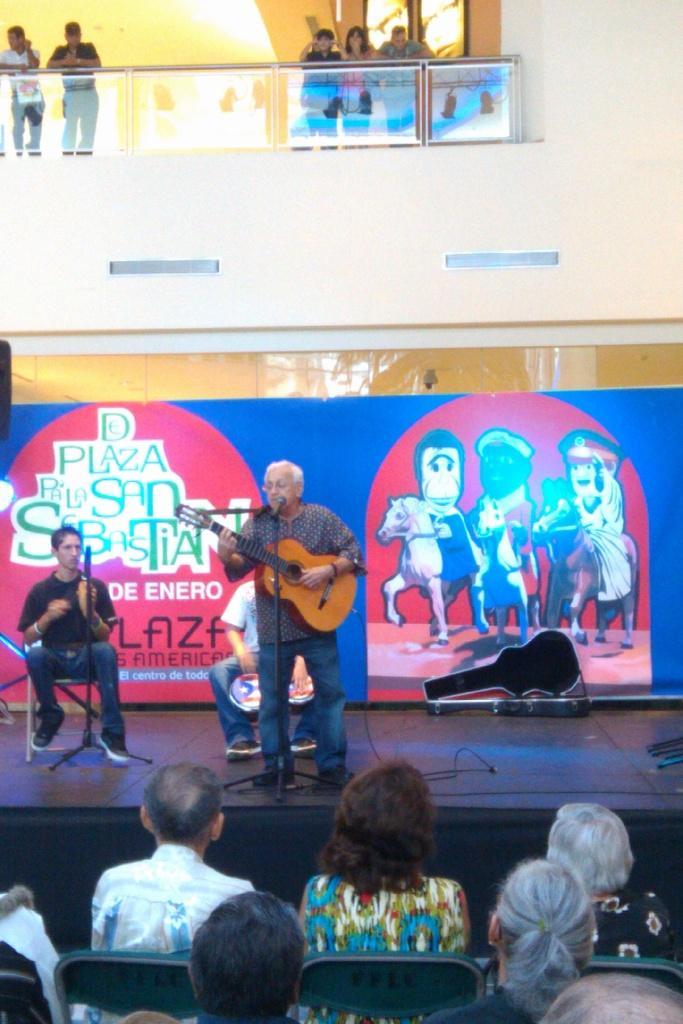Please provide a concise description of this image. In this image there is a man standing and playing guitar another man sitting in chair and at back ground there is a guitar case , hoarding , group of people standing , another group of people sitting in chair. 